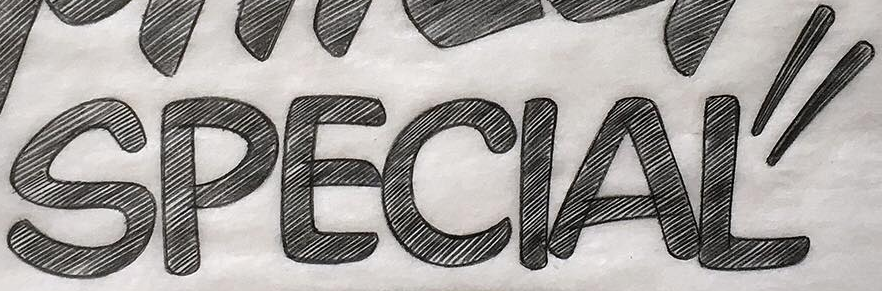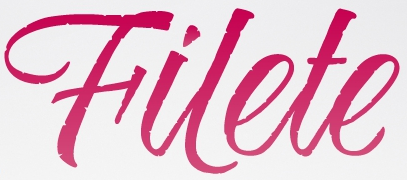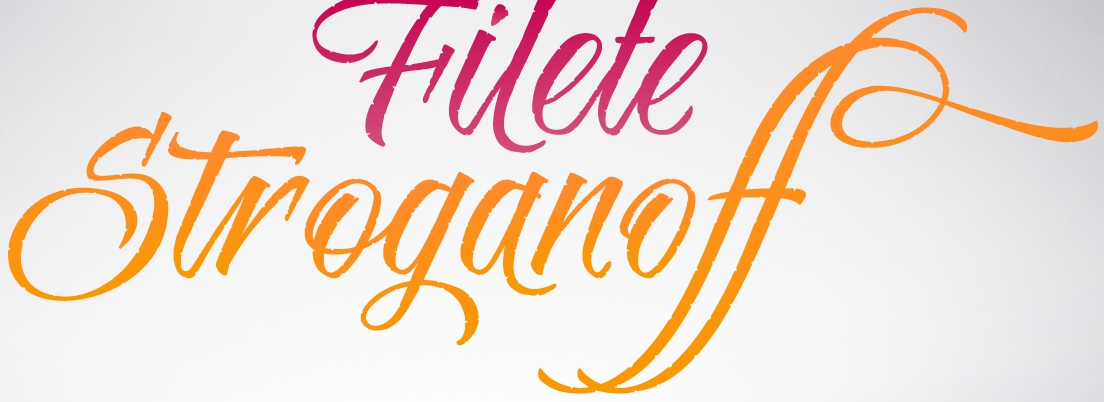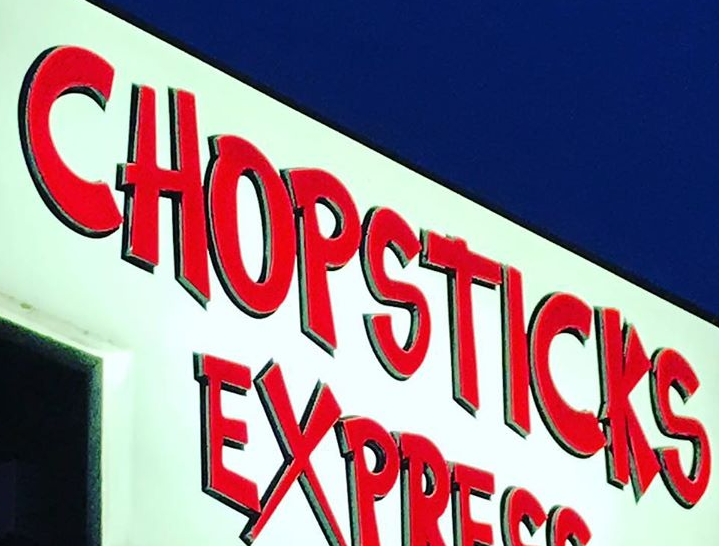What words can you see in these images in sequence, separated by a semicolon? SPECIAL"; Hilete; Stroganoff; CHOPSTICKS 